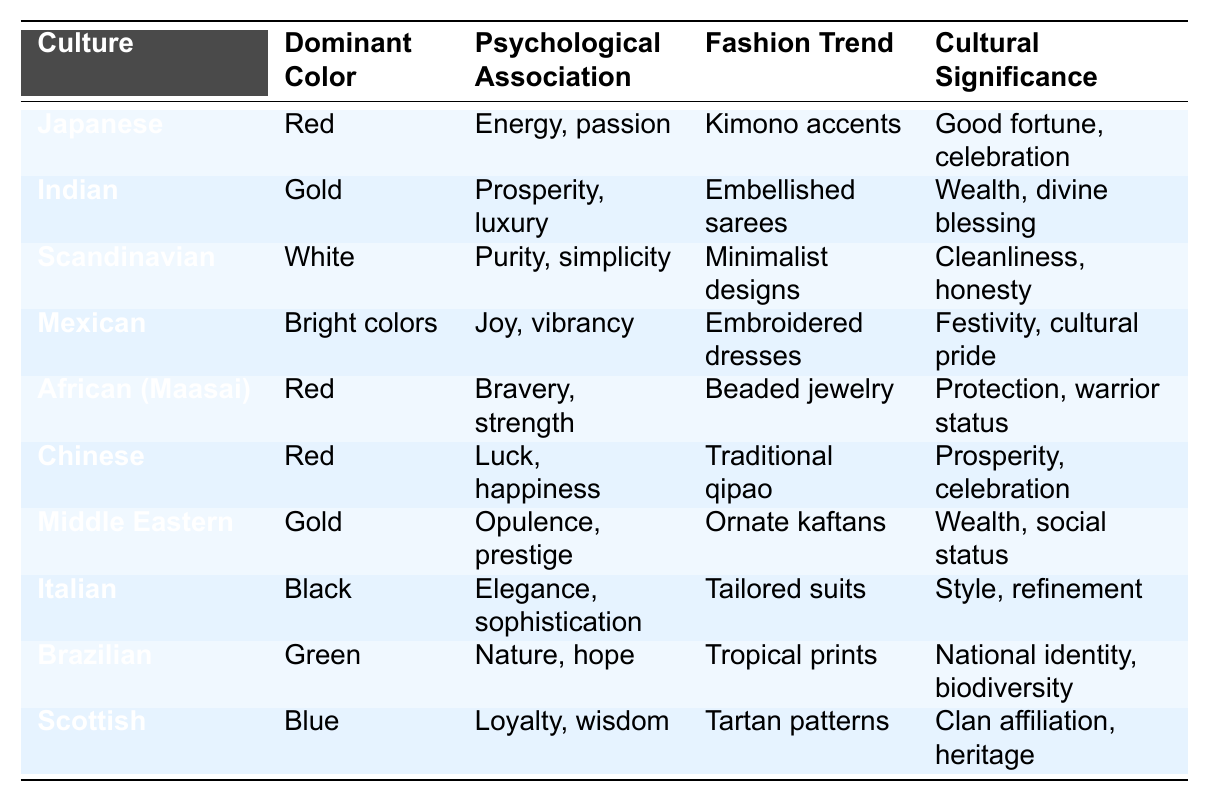What is the dominant color associated with Indian fashion trends? Referring to the table, the row for Indian culture shows that the dominant color is Gold.
Answer: Gold Which culture associates the color black with elegance? In the table, the Italian row indicates that the dominant color black is related to elegance and sophistication.
Answer: Italian What psychological association does the color red have in Japanese culture? The table states that in Japanese culture, red is associated with energy and passion.
Answer: Energy, passion Which two cultures use red as their dominant color? Looking at the table, both Japanese and African (Maasai) cultures list red as their dominant color.
Answer: Japanese and African (Maasai) What fashion trend is associated with green in Brazilian culture? The Brazilian culture row in the table shows that the fashion trend associated with green is tropical prints.
Answer: Tropical prints Does the Chinese culture have a psychological association with luck? The table indicates that Chinese culture associates red with luck and happiness, confirming the presence of luck as a psychological association.
Answer: Yes Which cultural significance is associated with bright colors in Mexican fashion? According to the Mexican row, bright colors are associated with festivity and cultural pride.
Answer: Festivity, cultural pride Is there a culture in the table that uses white as a dominant color? If so, which one? Yes, scanning the table reveals that Scandinavian culture is associated with the dominant color white.
Answer: Scandinavian Which culture has a fashion trend involving tailored suits? The table shows that Italian culture's fashion trend involves tailored suits, which is linked to their dominant color, black.
Answer: Italian What is the average number of distinct psychological associations across all cultures presented in the table? The unique psychological associations are: Energy and passion, Prosperity and luxury, Purity and simplicity, Joy and vibrancy, Bravery and strength, Luck and happiness, Opulence and prestige, Elegance and sophistication, Nature and hope, Loyalty and wisdom. This totals 10 unique associations, yielding an average of 1 association per culture.
Answer: 1 